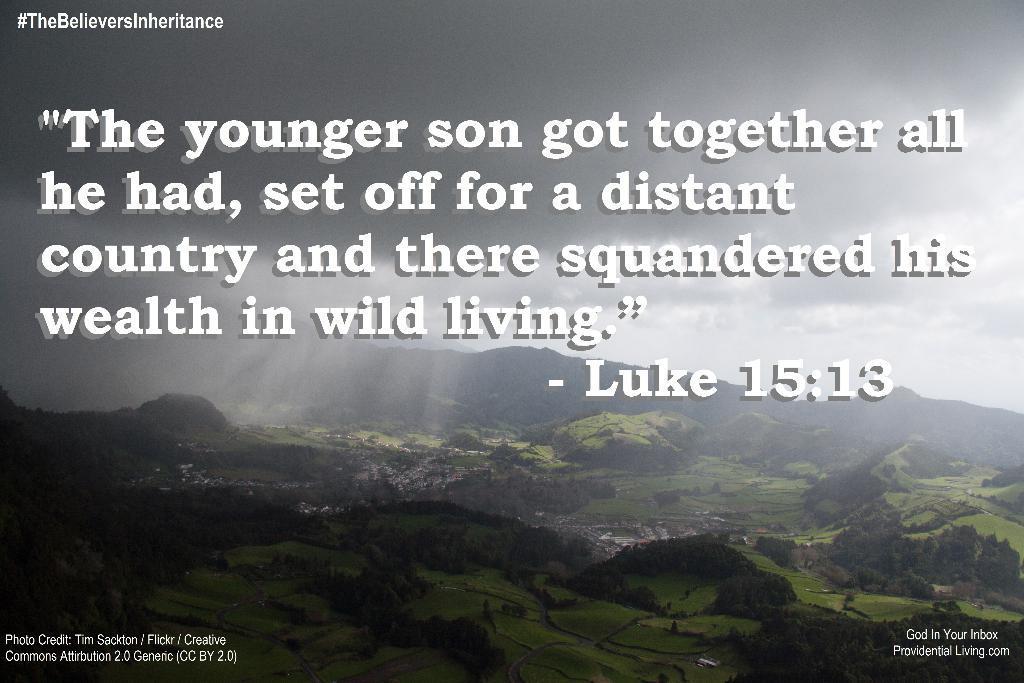Can you describe this image briefly? In this image we can see the text. In the background we can see the hills, trees, grass and there is a cloudy sky. 